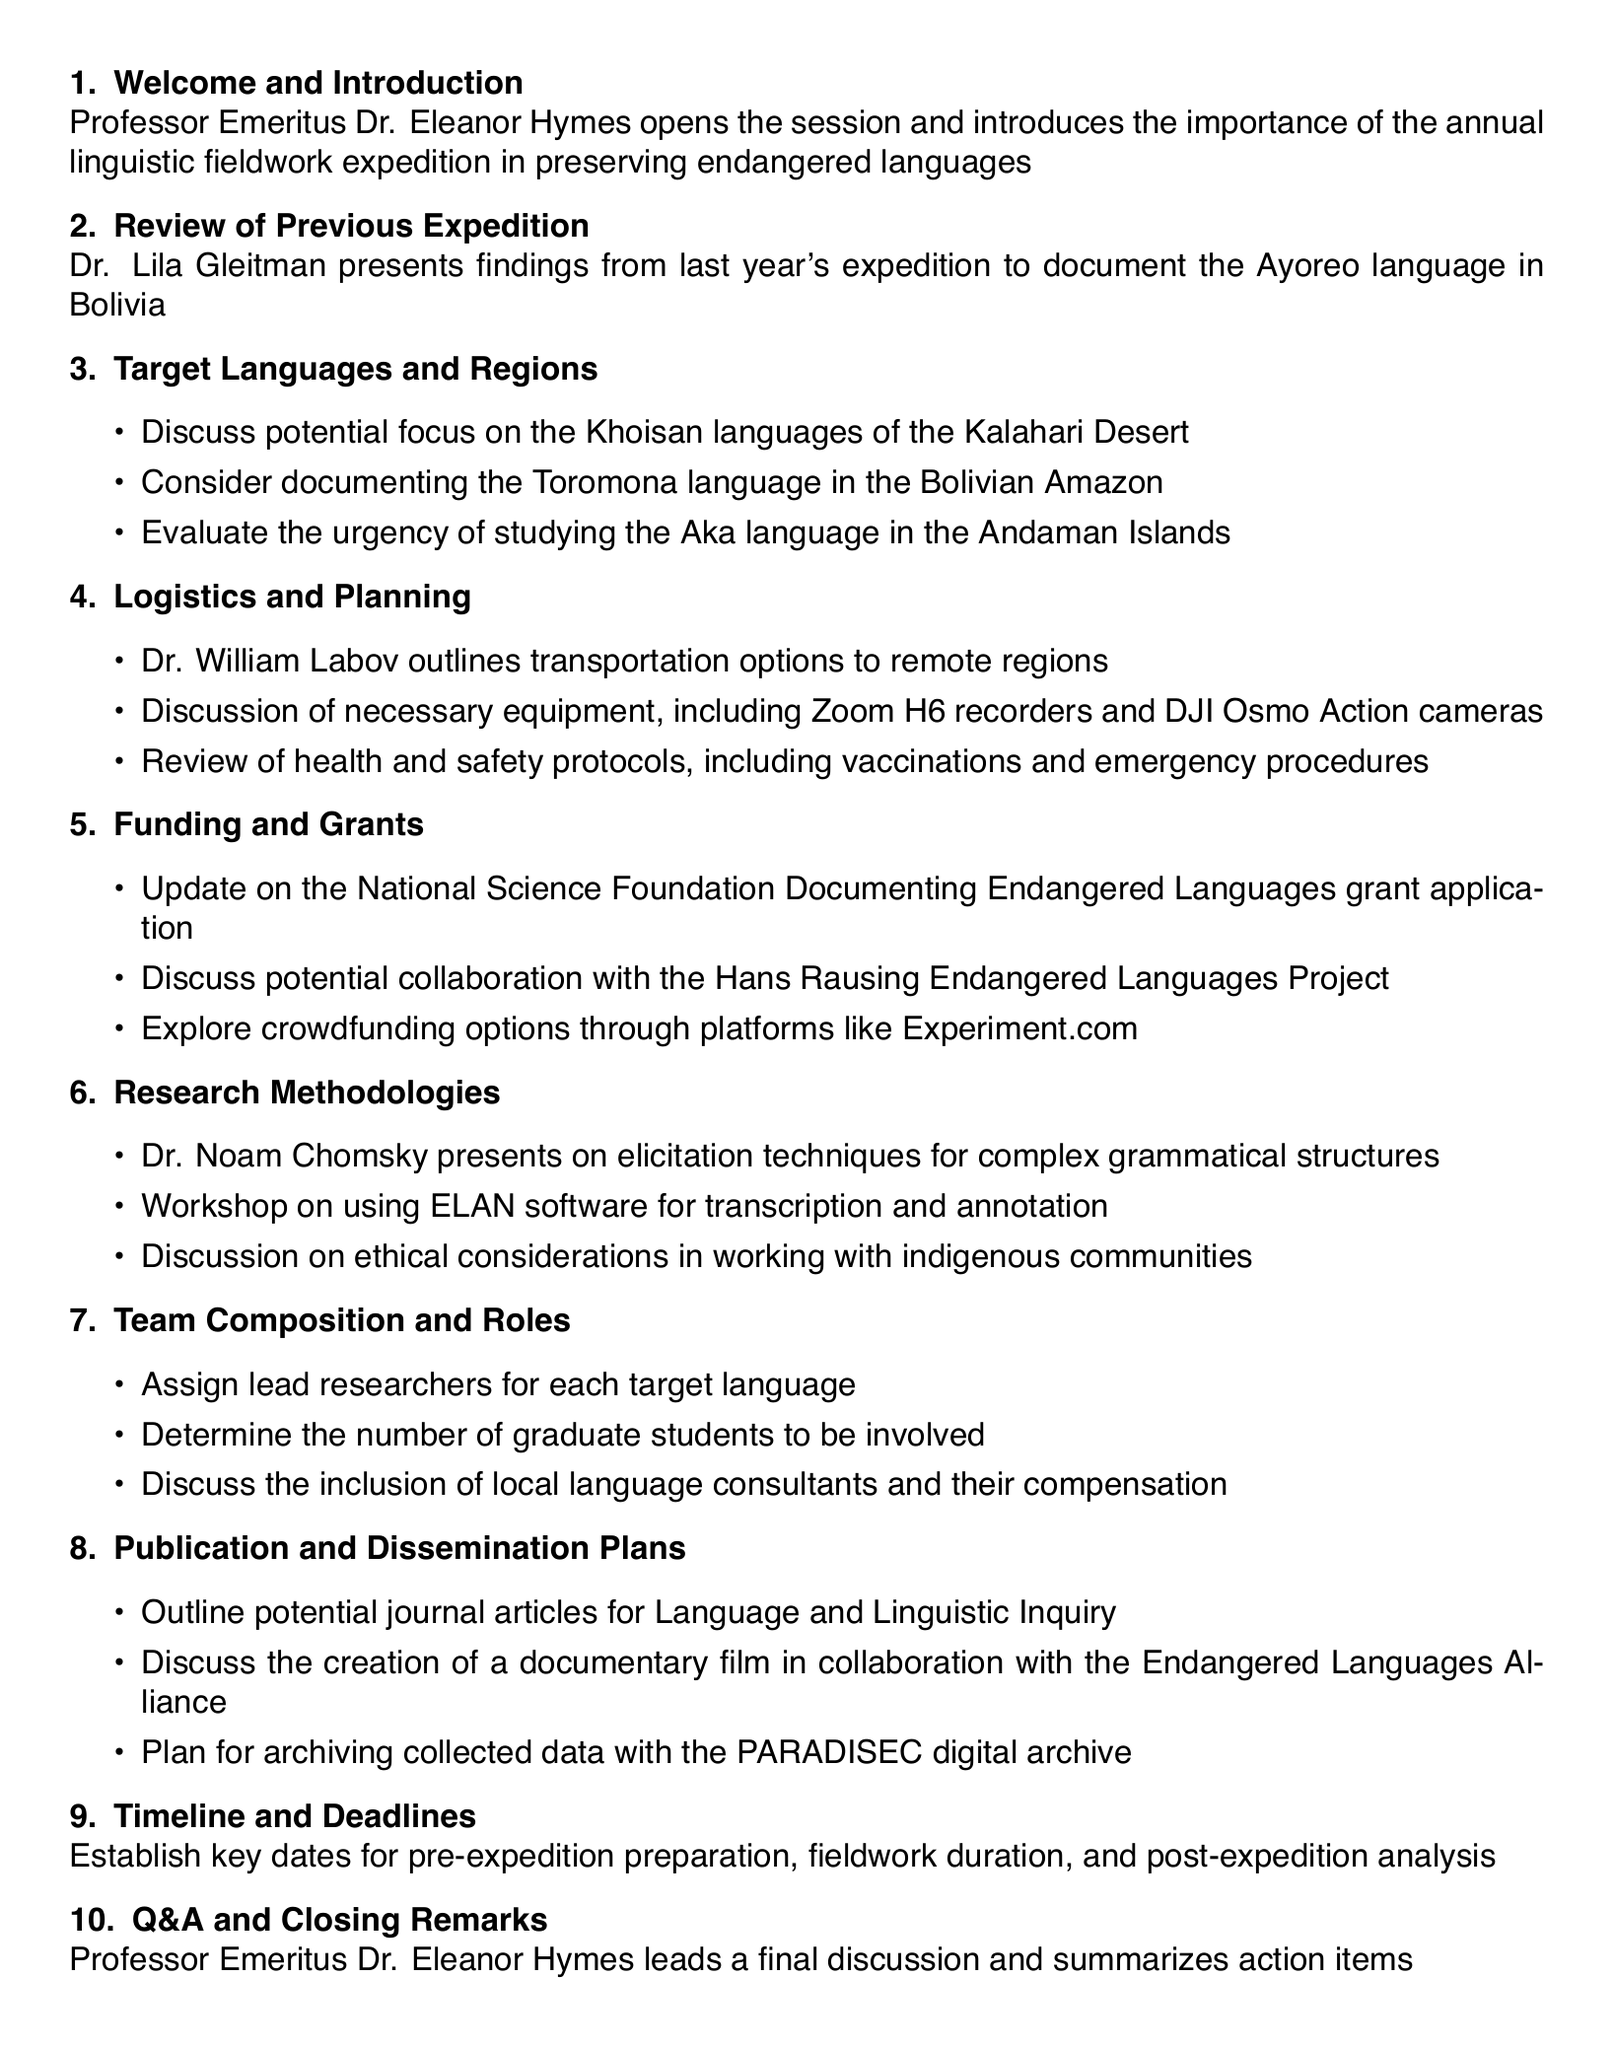What is the title of the document? The title is the main heading of the document, which identifies the purpose of the assembly.
Answer: Annual Linguistic Fieldwork Expedition Planning Session Who introduces the session? The person responsible for opening the session is mentioned in the welcome section.
Answer: Professor Emeritus Dr. Eleanor Hymes Which language was documented in the previous expedition? This information is presented in the review section of the agenda, specifically regarding last year's expedition.
Answer: Ayoreo language How many target languages are mentioned for discussion? The number of languages proposed for focus is detailed in the target languages and regions section.
Answer: Three What is the funding source discussed in the meeting? This identifies the grant that is specifically mentioned in the funding and grants section of the agenda.
Answer: National Science Foundation Documenting Endangered Languages grant Who leads the discussion on research methodologies? This individual is identified in relation to the topic that is presented during the session.
Answer: Dr. Noam Chomsky What is mentioned as a potential medium for publication? This refers to the type of journal discussed for publication throughout the dissemination section of the agenda.
Answer: Language and Linguistic Inquiry What is one of the logistics items discussed? This refers to any necessary logistical detail mentioned regarding preparations for the expedition.
Answer: Transportation options What technology will be used for recording? This detail specifies the equipment outlined in the logistics and planning section of the document.
Answer: Zoom H6 recorders 